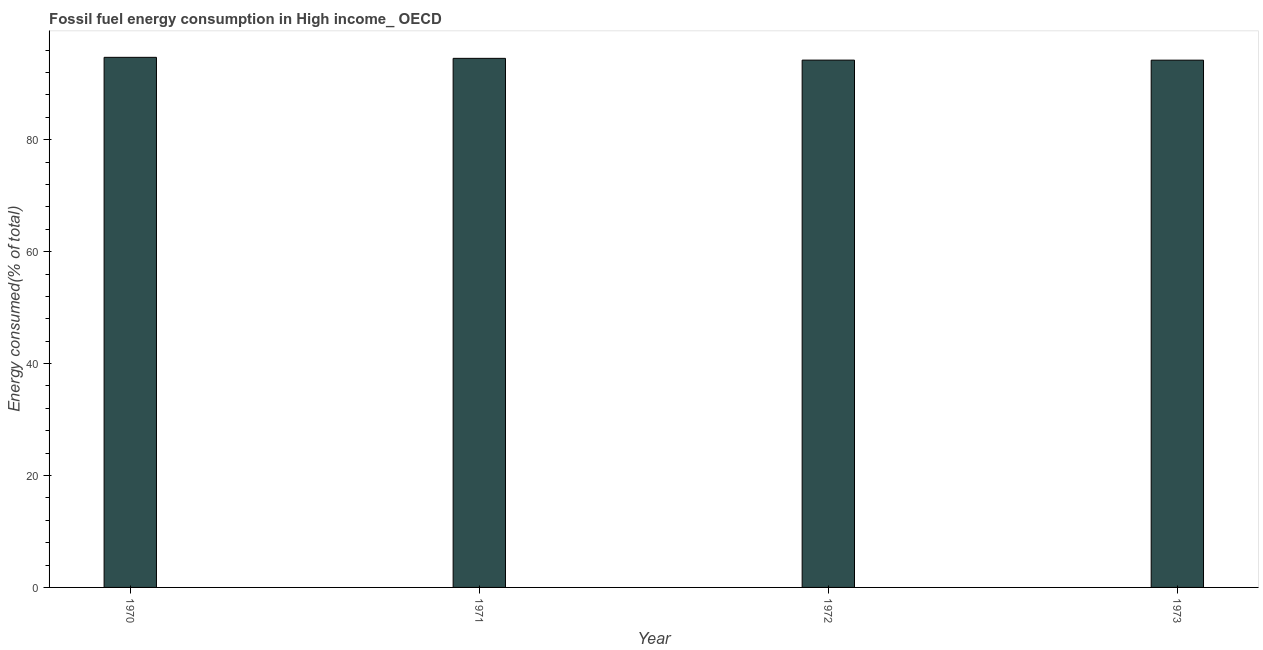Does the graph contain any zero values?
Your response must be concise. No. What is the title of the graph?
Your answer should be very brief. Fossil fuel energy consumption in High income_ OECD. What is the label or title of the Y-axis?
Offer a terse response. Energy consumed(% of total). What is the fossil fuel energy consumption in 1973?
Offer a very short reply. 94.21. Across all years, what is the maximum fossil fuel energy consumption?
Your answer should be very brief. 94.72. Across all years, what is the minimum fossil fuel energy consumption?
Your answer should be compact. 94.21. What is the sum of the fossil fuel energy consumption?
Offer a very short reply. 377.68. What is the difference between the fossil fuel energy consumption in 1971 and 1972?
Make the answer very short. 0.32. What is the average fossil fuel energy consumption per year?
Your answer should be compact. 94.42. What is the median fossil fuel energy consumption?
Your answer should be very brief. 94.38. Do a majority of the years between 1973 and 1972 (inclusive) have fossil fuel energy consumption greater than 28 %?
Make the answer very short. No. What is the ratio of the fossil fuel energy consumption in 1970 to that in 1972?
Your response must be concise. 1. Is the difference between the fossil fuel energy consumption in 1971 and 1972 greater than the difference between any two years?
Ensure brevity in your answer.  No. What is the difference between the highest and the second highest fossil fuel energy consumption?
Your answer should be compact. 0.18. What is the difference between the highest and the lowest fossil fuel energy consumption?
Give a very brief answer. 0.51. How many bars are there?
Offer a terse response. 4. Are all the bars in the graph horizontal?
Offer a terse response. No. What is the difference between two consecutive major ticks on the Y-axis?
Give a very brief answer. 20. What is the Energy consumed(% of total) of 1970?
Offer a terse response. 94.72. What is the Energy consumed(% of total) in 1971?
Give a very brief answer. 94.53. What is the Energy consumed(% of total) of 1972?
Offer a very short reply. 94.22. What is the Energy consumed(% of total) of 1973?
Make the answer very short. 94.21. What is the difference between the Energy consumed(% of total) in 1970 and 1971?
Offer a very short reply. 0.18. What is the difference between the Energy consumed(% of total) in 1970 and 1972?
Your answer should be compact. 0.5. What is the difference between the Energy consumed(% of total) in 1970 and 1973?
Offer a terse response. 0.51. What is the difference between the Energy consumed(% of total) in 1971 and 1972?
Give a very brief answer. 0.32. What is the difference between the Energy consumed(% of total) in 1971 and 1973?
Offer a very short reply. 0.32. What is the difference between the Energy consumed(% of total) in 1972 and 1973?
Make the answer very short. 0.01. What is the ratio of the Energy consumed(% of total) in 1970 to that in 1971?
Your response must be concise. 1. What is the ratio of the Energy consumed(% of total) in 1970 to that in 1972?
Make the answer very short. 1. What is the ratio of the Energy consumed(% of total) in 1971 to that in 1972?
Provide a succinct answer. 1. What is the ratio of the Energy consumed(% of total) in 1971 to that in 1973?
Make the answer very short. 1. 